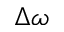<formula> <loc_0><loc_0><loc_500><loc_500>\Delta \omega</formula> 